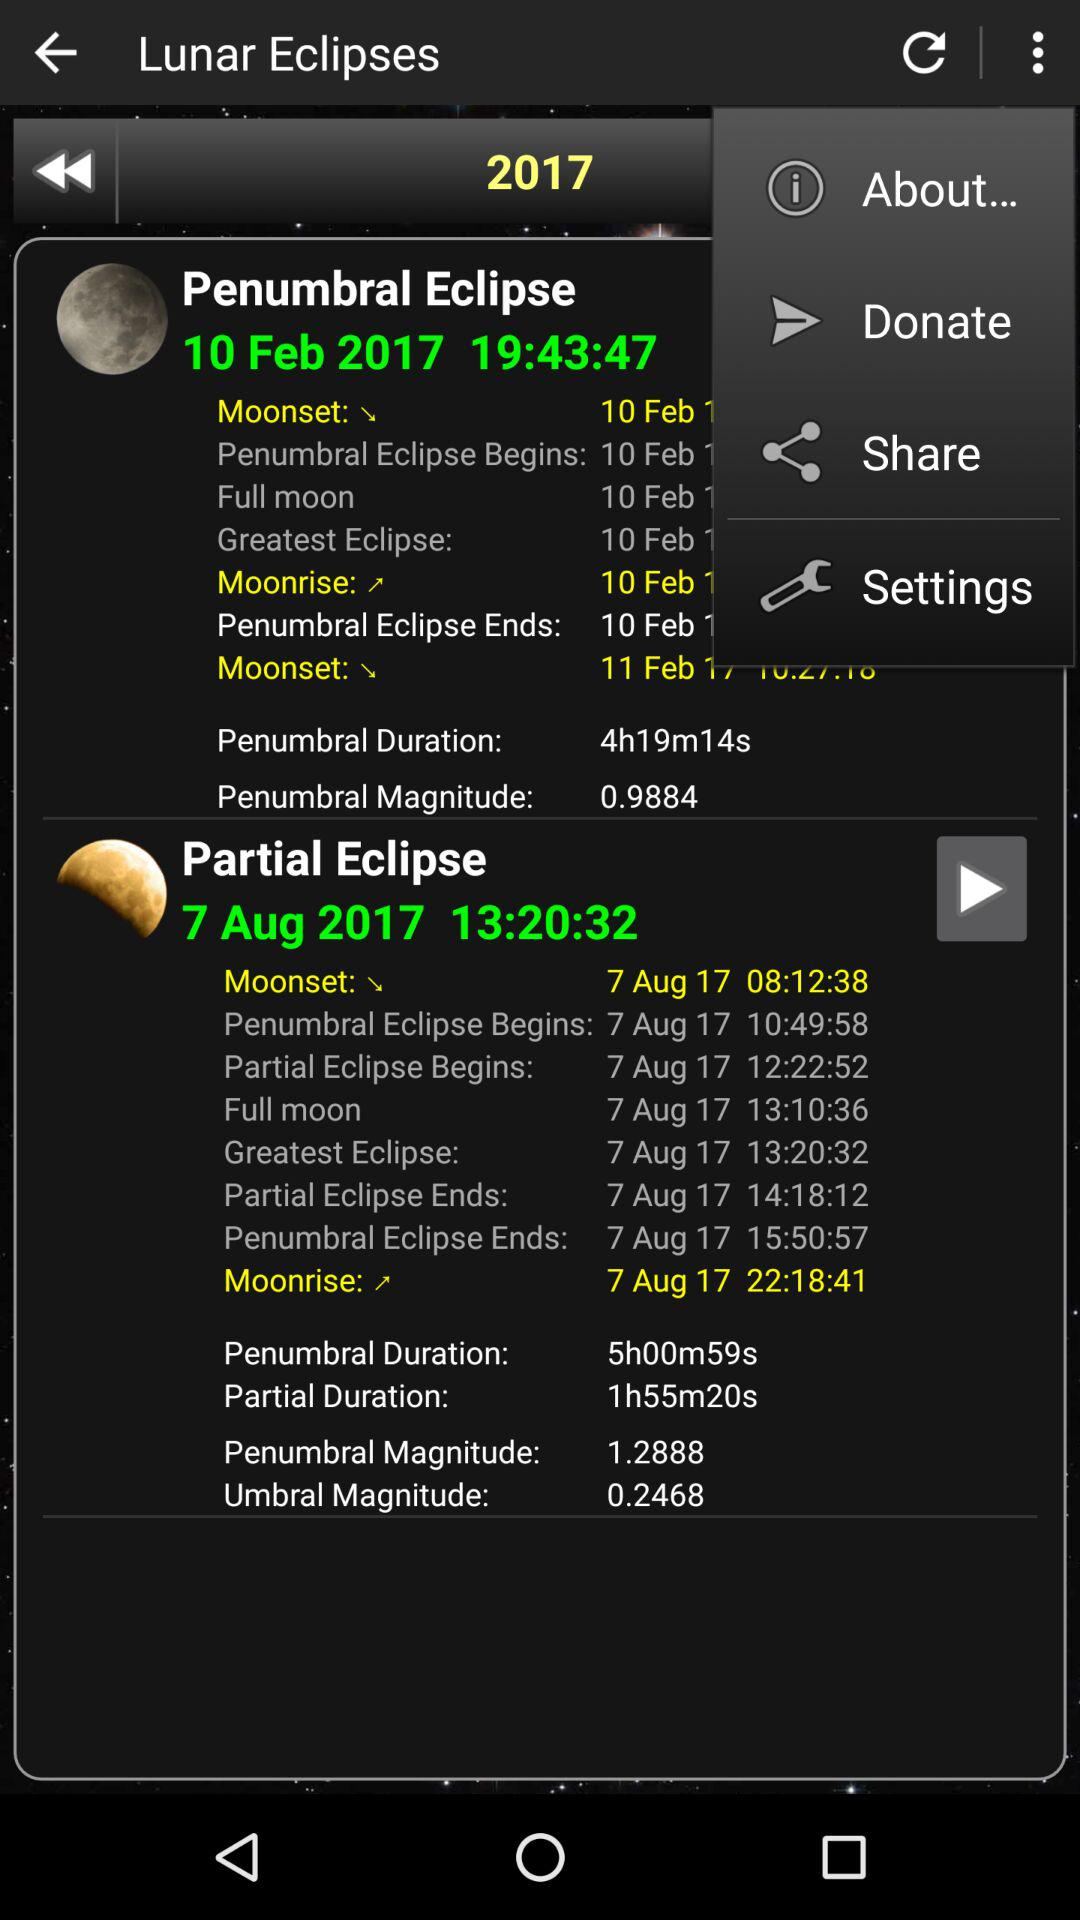What is the date of the partial eclipse? The date of the partial eclipse is August 7, 2017. 